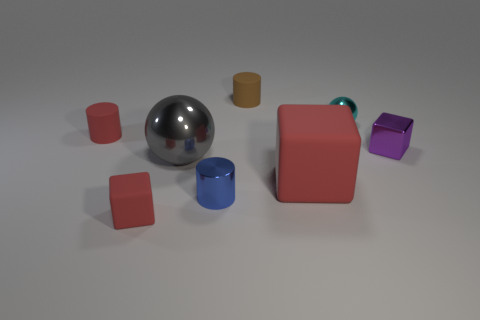Add 2 tiny blocks. How many objects exist? 10 Subtract all balls. How many objects are left? 6 Subtract all tiny cyan spheres. Subtract all big matte things. How many objects are left? 6 Add 6 small blue cylinders. How many small blue cylinders are left? 7 Add 5 small purple metal cubes. How many small purple metal cubes exist? 6 Subtract 0 purple cylinders. How many objects are left? 8 